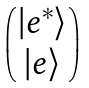Convert formula to latex. <formula><loc_0><loc_0><loc_500><loc_500>\begin{pmatrix} | e ^ { * } \rangle \\ | e \rangle \end{pmatrix}</formula> 